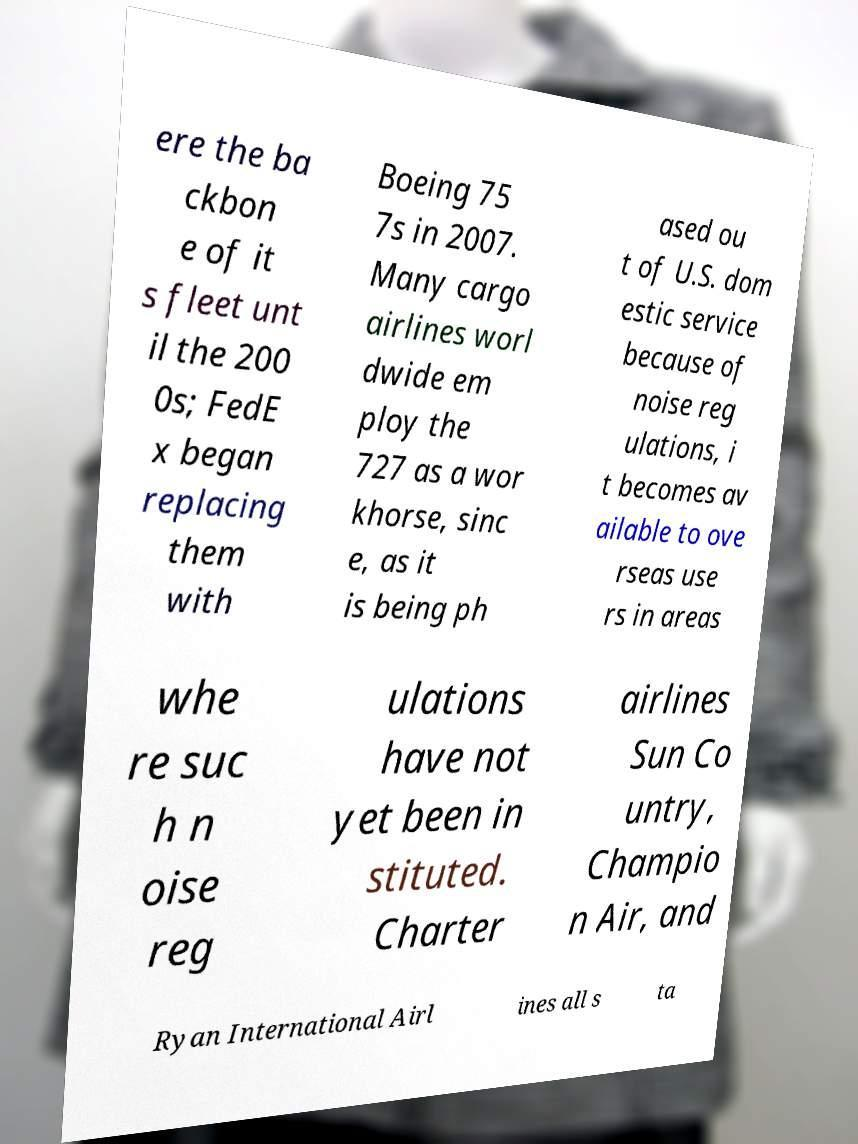For documentation purposes, I need the text within this image transcribed. Could you provide that? ere the ba ckbon e of it s fleet unt il the 200 0s; FedE x began replacing them with Boeing 75 7s in 2007. Many cargo airlines worl dwide em ploy the 727 as a wor khorse, sinc e, as it is being ph ased ou t of U.S. dom estic service because of noise reg ulations, i t becomes av ailable to ove rseas use rs in areas whe re suc h n oise reg ulations have not yet been in stituted. Charter airlines Sun Co untry, Champio n Air, and Ryan International Airl ines all s ta 